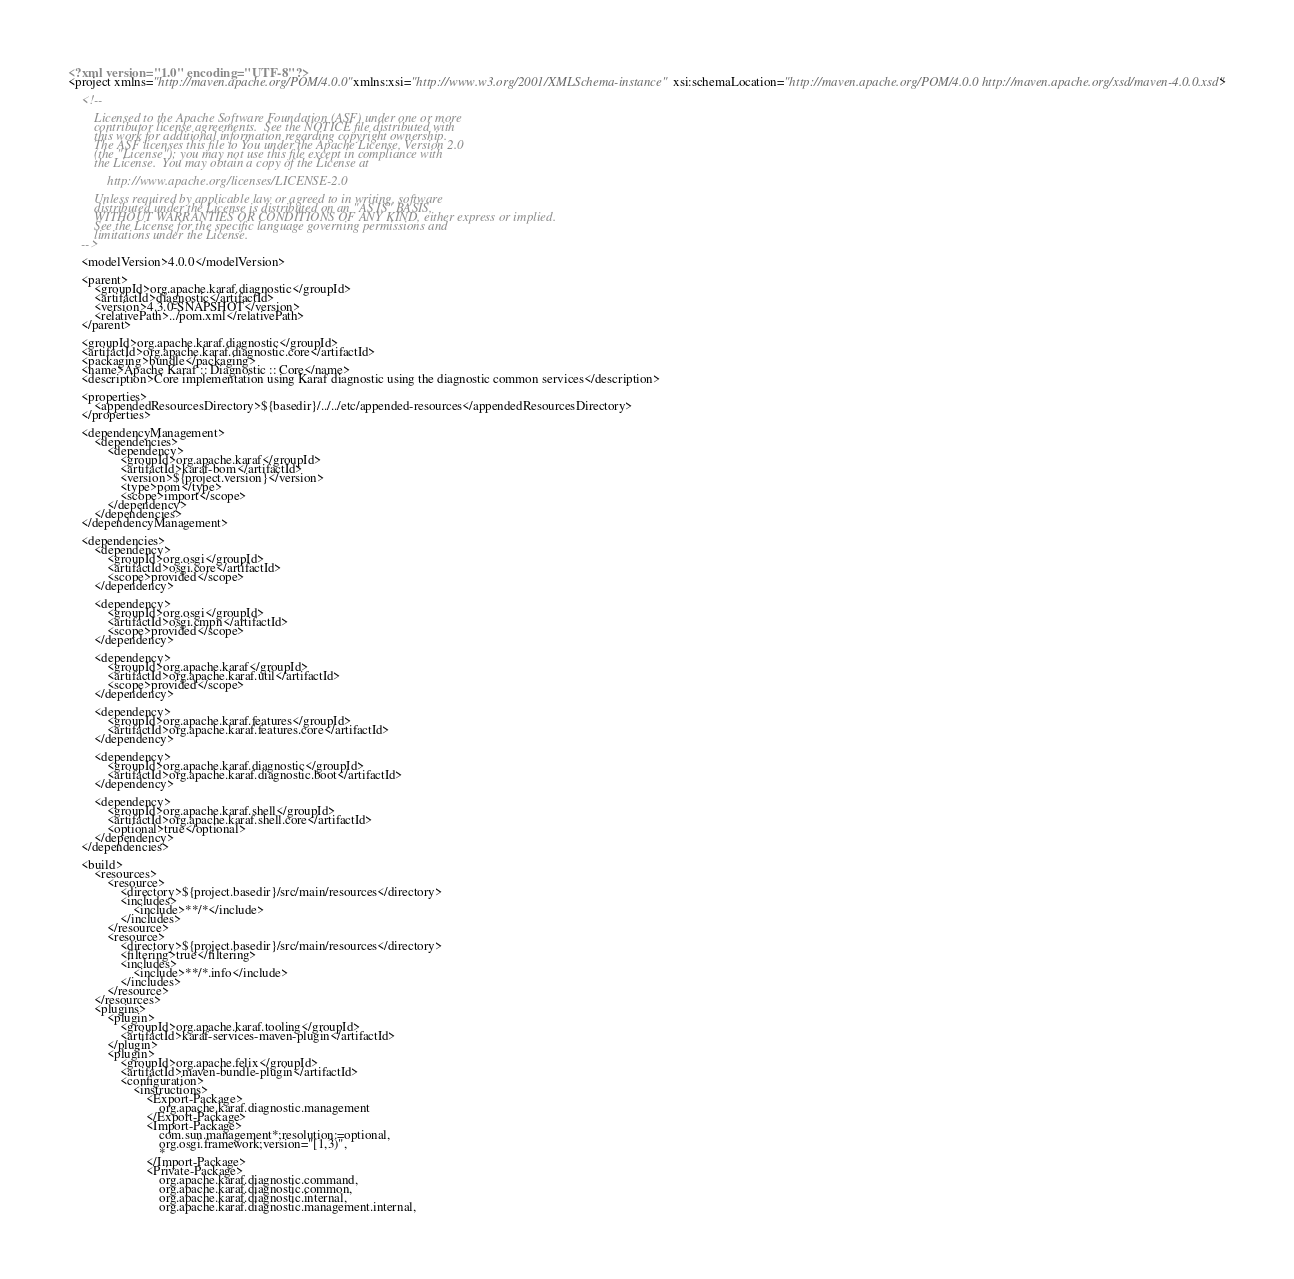Convert code to text. <code><loc_0><loc_0><loc_500><loc_500><_XML_><?xml version="1.0" encoding="UTF-8"?>
<project xmlns="http://maven.apache.org/POM/4.0.0" xmlns:xsi="http://www.w3.org/2001/XMLSchema-instance" xsi:schemaLocation="http://maven.apache.org/POM/4.0.0 http://maven.apache.org/xsd/maven-4.0.0.xsd">

    <!--

        Licensed to the Apache Software Foundation (ASF) under one or more
        contributor license agreements.  See the NOTICE file distributed with
        this work for additional information regarding copyright ownership.
        The ASF licenses this file to You under the Apache License, Version 2.0
        (the "License"); you may not use this file except in compliance with
        the License.  You may obtain a copy of the License at

            http://www.apache.org/licenses/LICENSE-2.0

        Unless required by applicable law or agreed to in writing, software
        distributed under the License is distributed on an "AS IS" BASIS,
        WITHOUT WARRANTIES OR CONDITIONS OF ANY KIND, either express or implied.
        See the License for the specific language governing permissions and
        limitations under the License.
    -->

    <modelVersion>4.0.0</modelVersion>

    <parent>
        <groupId>org.apache.karaf.diagnostic</groupId>
        <artifactId>diagnostic</artifactId>
        <version>4.3.0-SNAPSHOT</version>
        <relativePath>../pom.xml</relativePath>
    </parent>

    <groupId>org.apache.karaf.diagnostic</groupId>
    <artifactId>org.apache.karaf.diagnostic.core</artifactId>
    <packaging>bundle</packaging>
    <name>Apache Karaf :: Diagnostic :: Core</name>
    <description>Core implementation using Karaf diagnostic using the diagnostic common services</description>

    <properties>
        <appendedResourcesDirectory>${basedir}/../../etc/appended-resources</appendedResourcesDirectory>
    </properties>

    <dependencyManagement>
        <dependencies>
            <dependency>
                <groupId>org.apache.karaf</groupId>
                <artifactId>karaf-bom</artifactId>
                <version>${project.version}</version>
                <type>pom</type>
                <scope>import</scope>
            </dependency>
        </dependencies>
    </dependencyManagement>

    <dependencies>
        <dependency>
            <groupId>org.osgi</groupId>
            <artifactId>osgi.core</artifactId>
            <scope>provided</scope>
        </dependency>

        <dependency>
            <groupId>org.osgi</groupId>
            <artifactId>osgi.cmpn</artifactId>
            <scope>provided</scope>
        </dependency>

        <dependency>
            <groupId>org.apache.karaf</groupId>
            <artifactId>org.apache.karaf.util</artifactId>
            <scope>provided</scope>
        </dependency>

        <dependency>
            <groupId>org.apache.karaf.features</groupId>
            <artifactId>org.apache.karaf.features.core</artifactId>
        </dependency>

        <dependency>
            <groupId>org.apache.karaf.diagnostic</groupId>
            <artifactId>org.apache.karaf.diagnostic.boot</artifactId>
        </dependency>

        <dependency>
            <groupId>org.apache.karaf.shell</groupId>
            <artifactId>org.apache.karaf.shell.core</artifactId>
            <optional>true</optional>
        </dependency>
    </dependencies>

    <build>
        <resources>
            <resource>
                <directory>${project.basedir}/src/main/resources</directory>
                <includes>
                    <include>**/*</include>
                </includes>
            </resource>
            <resource>
                <directory>${project.basedir}/src/main/resources</directory>
                <filtering>true</filtering>
                <includes>
                    <include>**/*.info</include>
                </includes>
            </resource>
        </resources>
        <plugins>
            <plugin>
                <groupId>org.apache.karaf.tooling</groupId>
                <artifactId>karaf-services-maven-plugin</artifactId>
            </plugin>
            <plugin>
                <groupId>org.apache.felix</groupId>
                <artifactId>maven-bundle-plugin</artifactId>
                <configuration>
                    <instructions>
                        <Export-Package>
                            org.apache.karaf.diagnostic.management
                       	</Export-Package>
                        <Import-Package>
                            com.sun.management*;resolution:=optional,
                            org.osgi.framework;version="[1,3)",
                            *
                        </Import-Package>
                        <Private-Package>
                            org.apache.karaf.diagnostic.command,
                            org.apache.karaf.diagnostic.common,
                            org.apache.karaf.diagnostic.internal,
                            org.apache.karaf.diagnostic.management.internal,</code> 